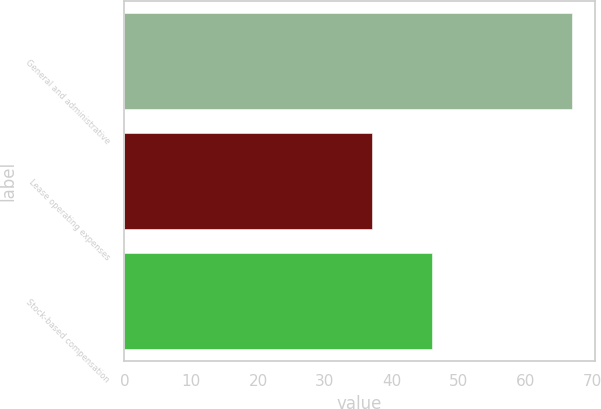Convert chart. <chart><loc_0><loc_0><loc_500><loc_500><bar_chart><fcel>General and administrative<fcel>Lease operating expenses<fcel>Stock-based compensation<nl><fcel>67<fcel>37<fcel>46<nl></chart> 